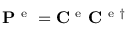Convert formula to latex. <formula><loc_0><loc_0><loc_500><loc_500>P ^ { e } = C ^ { e } C ^ { e \dagger }</formula> 